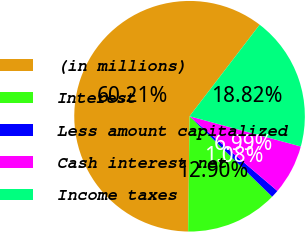<chart> <loc_0><loc_0><loc_500><loc_500><pie_chart><fcel>(in millions)<fcel>Interest<fcel>Less amount capitalized<fcel>Cash interest net<fcel>Income taxes<nl><fcel>60.21%<fcel>12.9%<fcel>1.08%<fcel>6.99%<fcel>18.82%<nl></chart> 